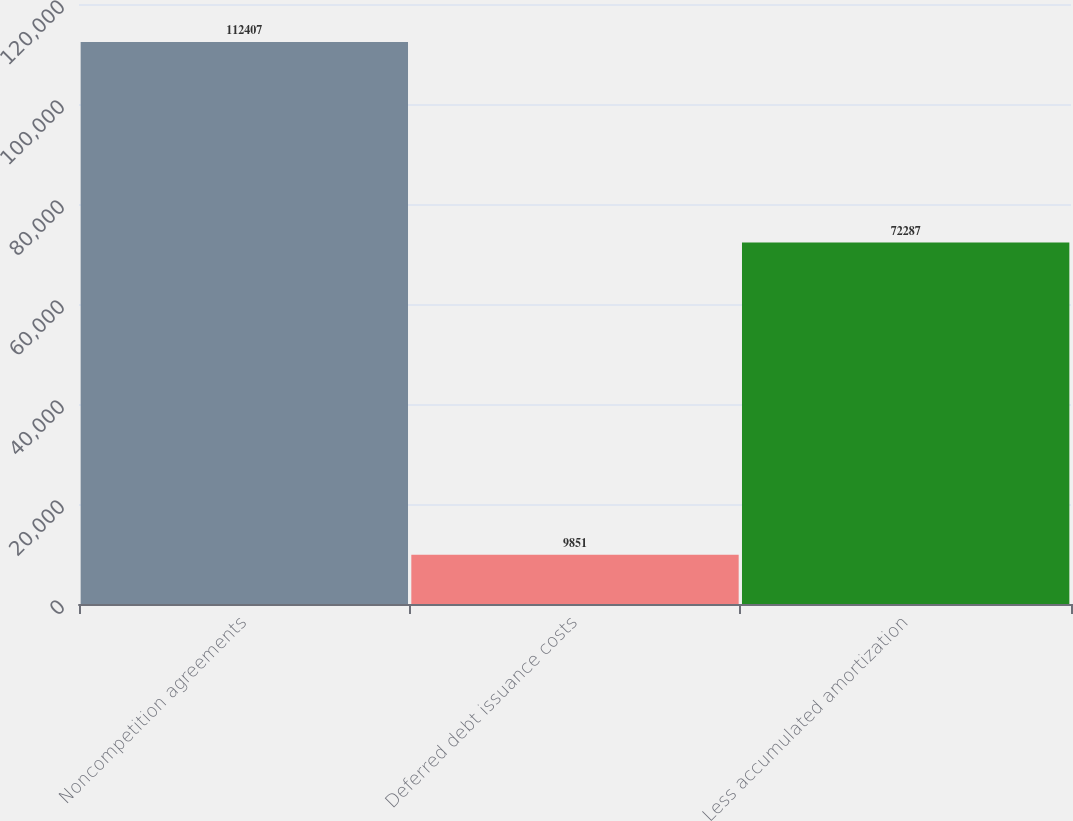Convert chart. <chart><loc_0><loc_0><loc_500><loc_500><bar_chart><fcel>Noncompetition agreements<fcel>Deferred debt issuance costs<fcel>Less accumulated amortization<nl><fcel>112407<fcel>9851<fcel>72287<nl></chart> 